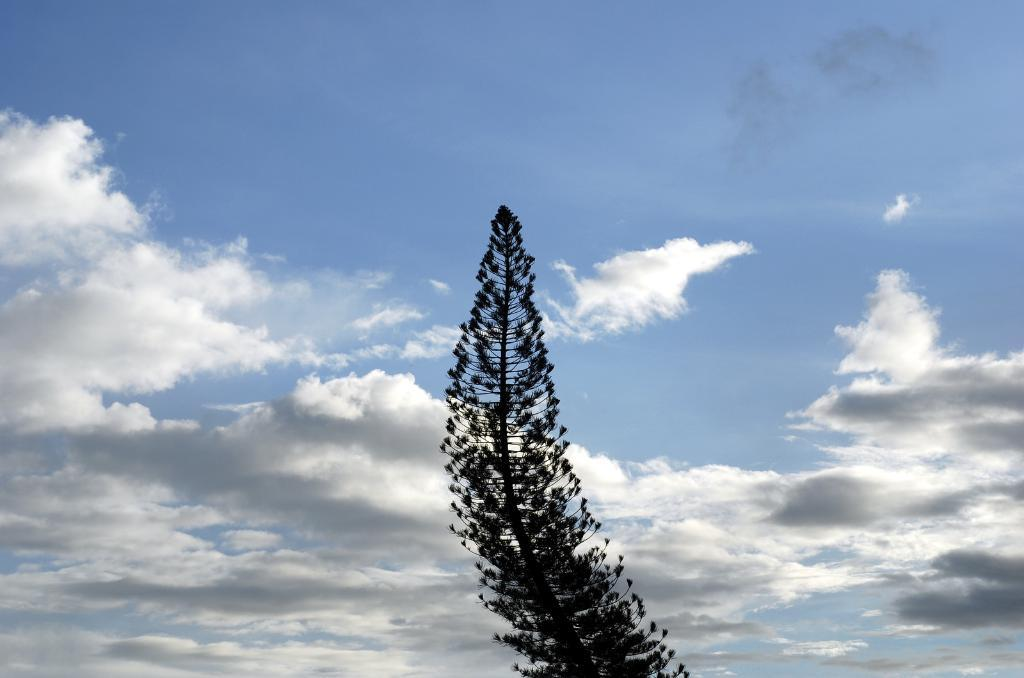What type of plant is present in the image? There is a tree with branches and leaves in the image. What can be seen in the sky in the image? There are clouds visible in the sky. How many cats are playing with kittens in the advertisement in the image? There is no advertisement or cats and kittens present in the image; it features a tree with branches and leaves and clouds in the sky. 